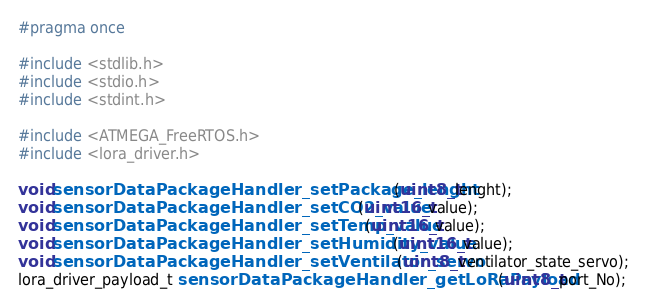<code> <loc_0><loc_0><loc_500><loc_500><_C_>

#pragma once

#include <stdlib.h>
#include <stdio.h>
#include <stdint.h>

#include <ATMEGA_FreeRTOS.h>
#include <lora_driver.h>

void sensorDataPackageHandler_setPackage_lenght(uint8_t lenght);
void sensorDataPackageHandler_setCO2_value(uint16_t value);
void sensorDataPackageHandler_setTemp_value(uint16_t value);
void sensorDataPackageHandler_setHumidity_value(uint16_t value);
void sensorDataPackageHandler_setVentilator_servo(uint8_t ventilator_state_servo);
lora_driver_payload_t sensorDataPackageHandler_getLoRaPayload(uint8_t port_No);</code> 